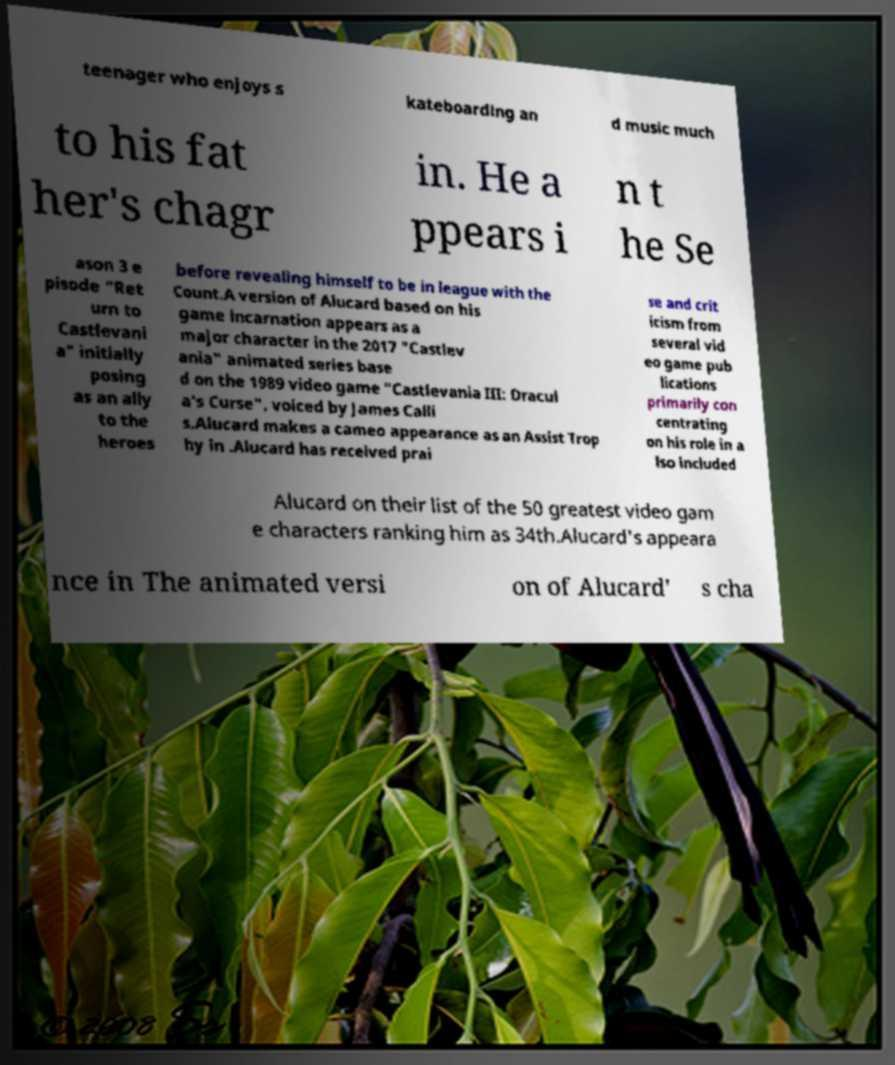Could you extract and type out the text from this image? teenager who enjoys s kateboarding an d music much to his fat her's chagr in. He a ppears i n t he Se ason 3 e pisode "Ret urn to Castlevani a" initially posing as an ally to the heroes before revealing himself to be in league with the Count.A version of Alucard based on his game incarnation appears as a major character in the 2017 "Castlev ania" animated series base d on the 1989 video game "Castlevania III: Dracul a's Curse", voiced by James Calli s.Alucard makes a cameo appearance as an Assist Trop hy in .Alucard has received prai se and crit icism from several vid eo game pub lications primarily con centrating on his role in a lso included Alucard on their list of the 50 greatest video gam e characters ranking him as 34th.Alucard's appeara nce in The animated versi on of Alucard' s cha 